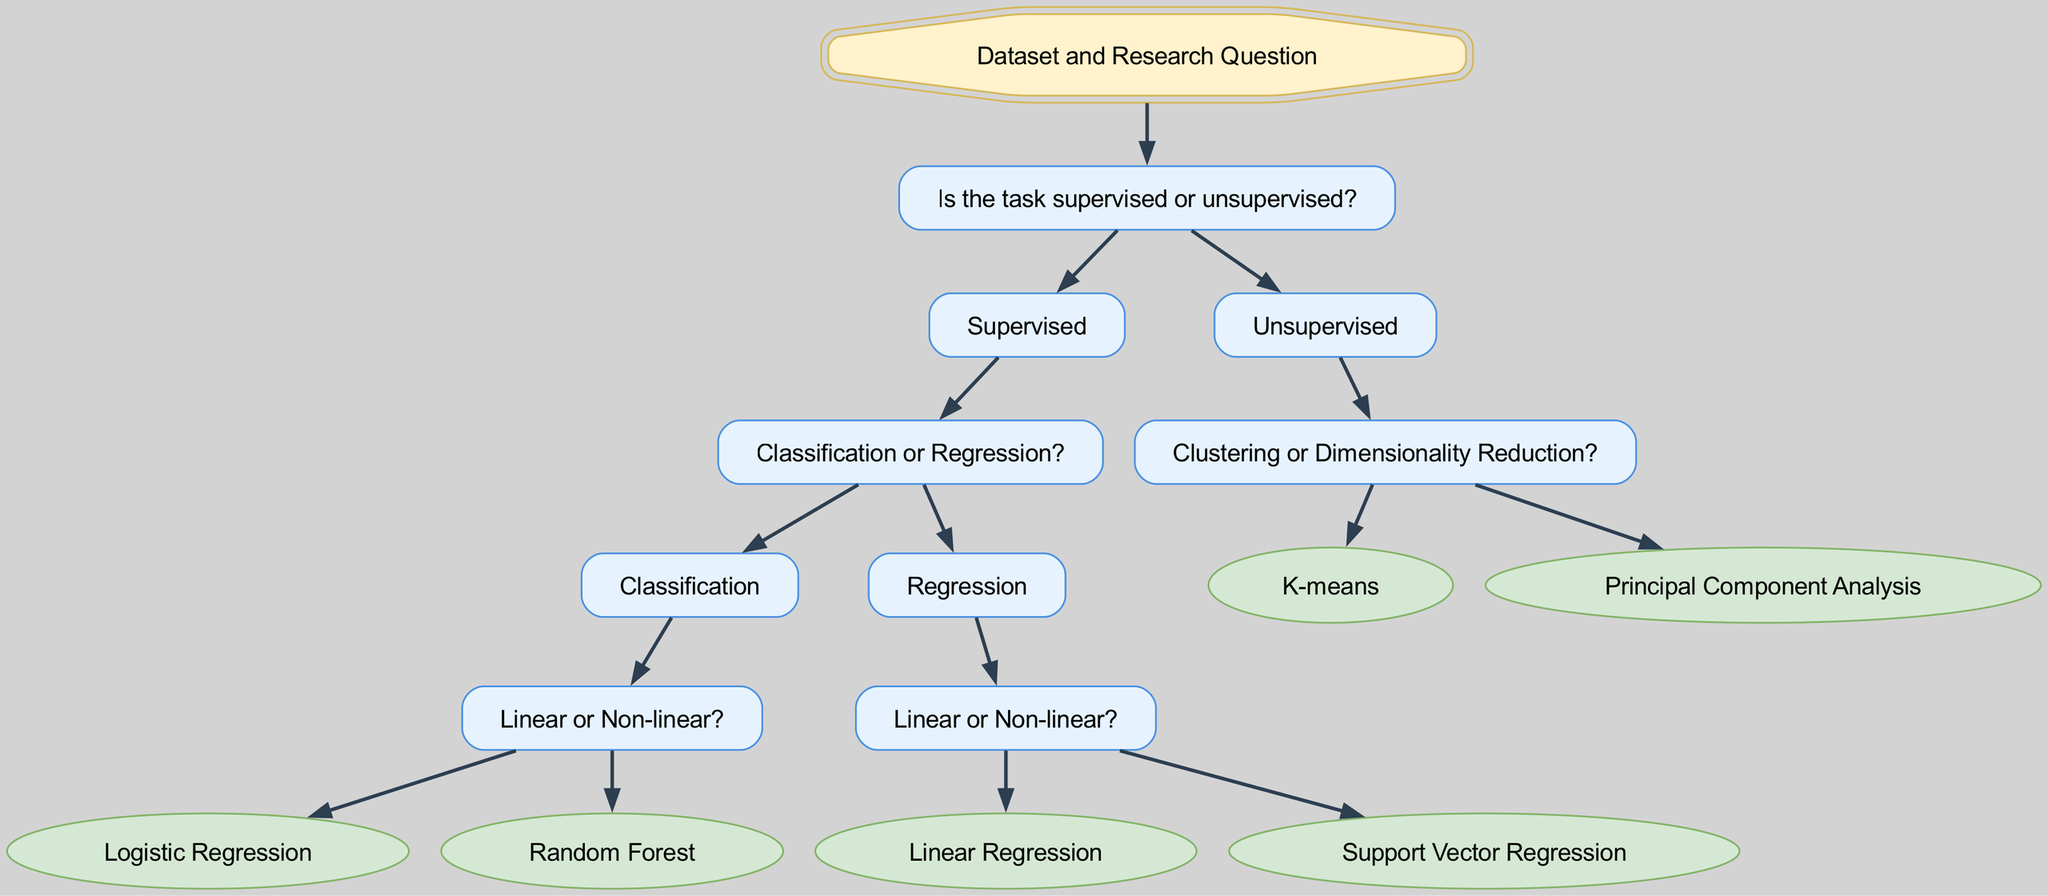What is the root node of the decision tree? The root node, which represents the starting point of the decision-making process in the diagram, is labeled "Dataset and Research Question."
Answer: Dataset and Research Question How many main branches does the decision tree have? The decision tree has two main branches stemming from the root node: one for "Supervised" tasks and another for "Unsupervised" tasks.
Answer: 2 What is the leaf node for linear regression? The leaf node that represents linear regression indicates the choice of algorithm when the task is regression and linear. This node is labeled "Linear Regression."
Answer: Linear Regression Which algorithm is associated with Non-linear classification? In the decision tree, the algorithm associated with Non-linear classification is indicated in the corresponding leaf node as "Random Forest."
Answer: Random Forest What type of learning task does "K-means" refer to? The "K-means" algorithm is found as a leaf under the "Clustering" category of the "Unsupervised" branch. Therefore, it refers to an unsupervised learning task.
Answer: Unsupervised What question do we ask after determining the task is supervised? After confirming that the task is supervised, the next question is focused on whether the supervised task is for classification or regression.
Answer: Classification or Regression Which algorithm should be chosen for non-linear regression tasks? The diagram indicates that for non-linear regression tasks, the selected algorithm is "Support Vector Regression."
Answer: Support Vector Regression How does the tree differentiate between Linear and Non-linear tasks in classification? The decision tree differentiates between Linear and Non-linear tasks in classification by asking whether the classification task is linear or non-linear after the classification choice has been made.
Answer: By asking if it is linear or non-linear What is the purpose of the decision tree? The purpose of the decision tree is to guide users in selecting the most appropriate machine learning algorithm based on the characteristics of the dataset and the research question posed.
Answer: To determine the suitable algorithm 